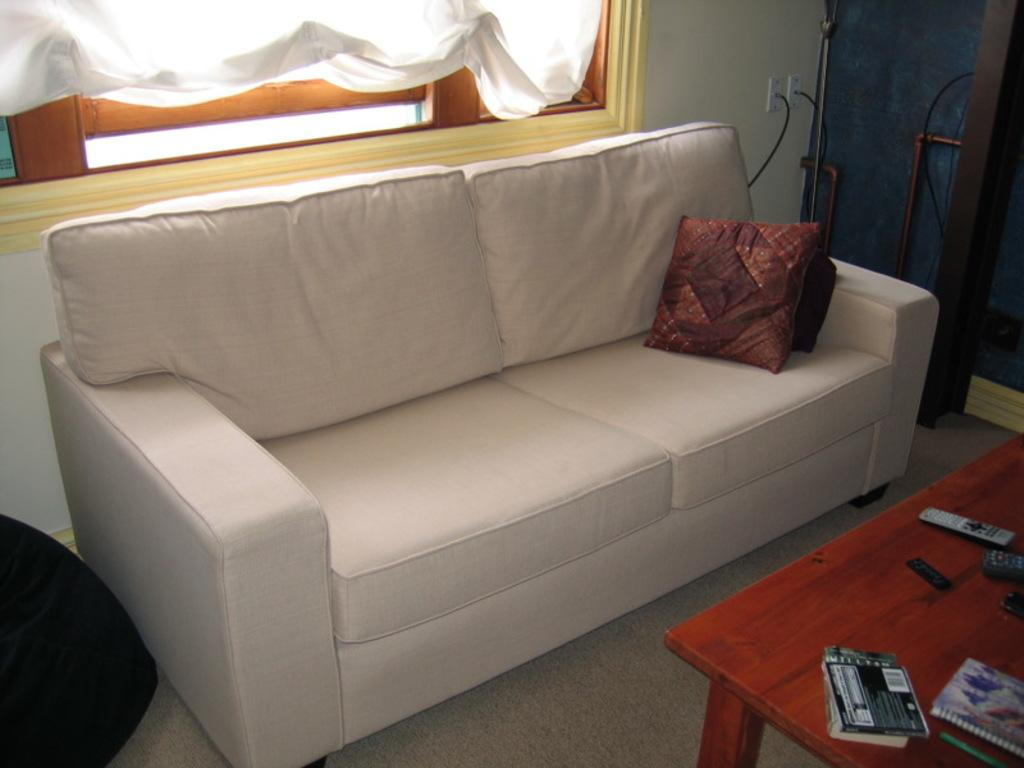What can be seen in the image that allows light and air to enter the room? There is a window in the image. What type of furniture is present in the image for seating? There is a sofa in the image. What items are present in the image for comfort while sitting on the sofa? There are pillows in the image. What piece of furniture is present in the image for placing objects? There is a table in the image. What items can be seen on the table that are related to reading or writing? There are books and a pen on the table. What item can be seen on the table that is used for controlling electronic devices? There is a remote on the table. What type of quartz can be seen on the table in the image? There is no quartz present on the table in the image. How does the digestion process of the person in the image appear to be going? There is no indication of a person or their digestion process in the image. 